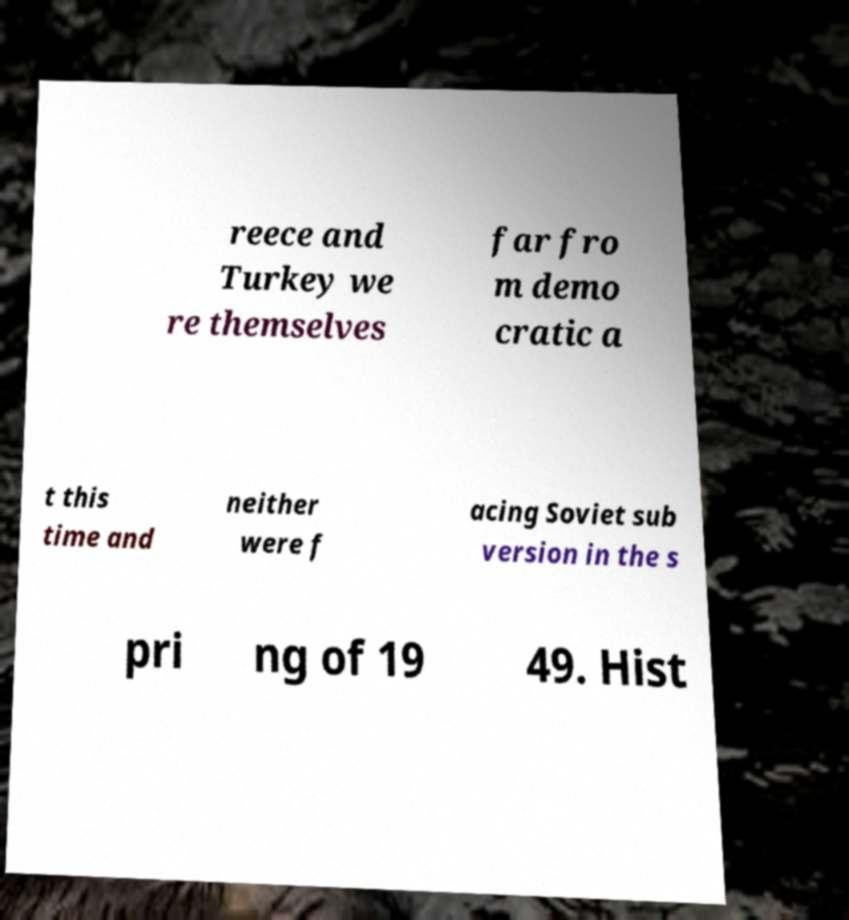Can you accurately transcribe the text from the provided image for me? reece and Turkey we re themselves far fro m demo cratic a t this time and neither were f acing Soviet sub version in the s pri ng of 19 49. Hist 